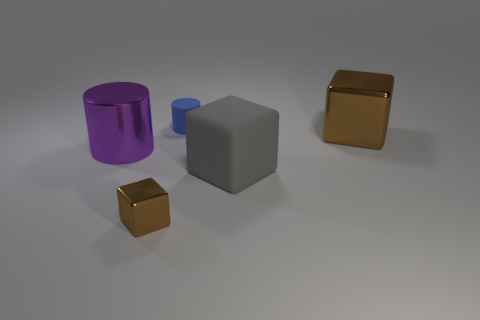What material is the purple object that is the same shape as the small blue thing?
Offer a very short reply. Metal. Is there any other thing that is the same material as the big gray thing?
Keep it short and to the point. Yes. The thing that is both behind the large purple metallic cylinder and to the left of the gray matte cube is made of what material?
Offer a very short reply. Rubber. How many other small brown things are the same shape as the tiny brown thing?
Make the answer very short. 0. There is a big metal cylinder in front of the brown shiny block on the right side of the small blue matte thing; what color is it?
Your answer should be compact. Purple. Is the number of big cylinders that are in front of the rubber cylinder the same as the number of shiny cylinders?
Your answer should be very brief. Yes. Are there any brown metallic cubes that have the same size as the metal cylinder?
Keep it short and to the point. Yes. There is a gray rubber block; does it have the same size as the thing that is to the right of the gray rubber block?
Provide a short and direct response. Yes. Is the number of matte cubes to the right of the tiny brown metal cube the same as the number of big purple shiny cylinders that are behind the large brown object?
Make the answer very short. No. There is a big object that is the same color as the small block; what shape is it?
Provide a succinct answer. Cube. 